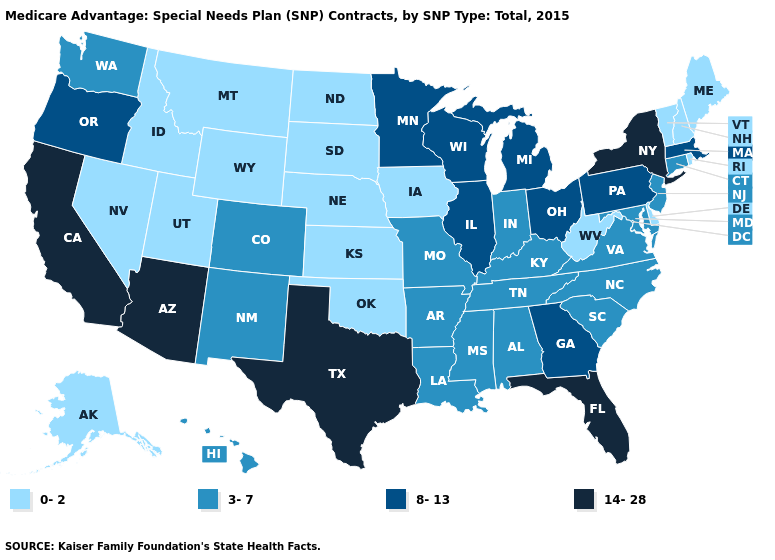Name the states that have a value in the range 0-2?
Answer briefly. Alaska, Delaware, Iowa, Idaho, Kansas, Maine, Montana, North Dakota, Nebraska, New Hampshire, Nevada, Oklahoma, Rhode Island, South Dakota, Utah, Vermont, West Virginia, Wyoming. What is the value of Rhode Island?
Give a very brief answer. 0-2. Does Arizona have the highest value in the West?
Give a very brief answer. Yes. Does New York have the highest value in the USA?
Write a very short answer. Yes. How many symbols are there in the legend?
Concise answer only. 4. What is the value of Nebraska?
Keep it brief. 0-2. What is the lowest value in states that border South Dakota?
Answer briefly. 0-2. What is the value of Hawaii?
Give a very brief answer. 3-7. Name the states that have a value in the range 0-2?
Answer briefly. Alaska, Delaware, Iowa, Idaho, Kansas, Maine, Montana, North Dakota, Nebraska, New Hampshire, Nevada, Oklahoma, Rhode Island, South Dakota, Utah, Vermont, West Virginia, Wyoming. Is the legend a continuous bar?
Keep it brief. No. Does Connecticut have the lowest value in the Northeast?
Keep it brief. No. What is the value of Nevada?
Short answer required. 0-2. Among the states that border Idaho , does Nevada have the highest value?
Keep it brief. No. What is the highest value in the MidWest ?
Concise answer only. 8-13. 